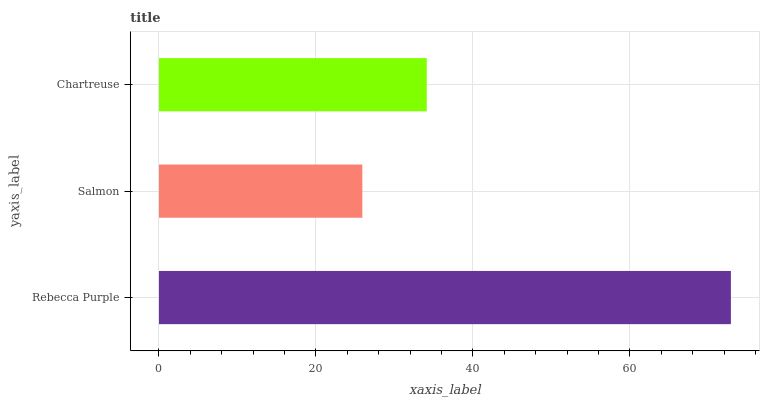Is Salmon the minimum?
Answer yes or no. Yes. Is Rebecca Purple the maximum?
Answer yes or no. Yes. Is Chartreuse the minimum?
Answer yes or no. No. Is Chartreuse the maximum?
Answer yes or no. No. Is Chartreuse greater than Salmon?
Answer yes or no. Yes. Is Salmon less than Chartreuse?
Answer yes or no. Yes. Is Salmon greater than Chartreuse?
Answer yes or no. No. Is Chartreuse less than Salmon?
Answer yes or no. No. Is Chartreuse the high median?
Answer yes or no. Yes. Is Chartreuse the low median?
Answer yes or no. Yes. Is Rebecca Purple the high median?
Answer yes or no. No. Is Rebecca Purple the low median?
Answer yes or no. No. 